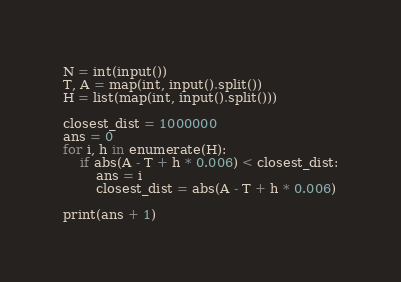Convert code to text. <code><loc_0><loc_0><loc_500><loc_500><_Python_>N = int(input())
T, A = map(int, input().split())
H = list(map(int, input().split()))

closest_dist = 1000000
ans = 0
for i, h in enumerate(H):
    if abs(A - T + h * 0.006) < closest_dist:
        ans = i
        closest_dist = abs(A - T + h * 0.006)
        
print(ans + 1)</code> 